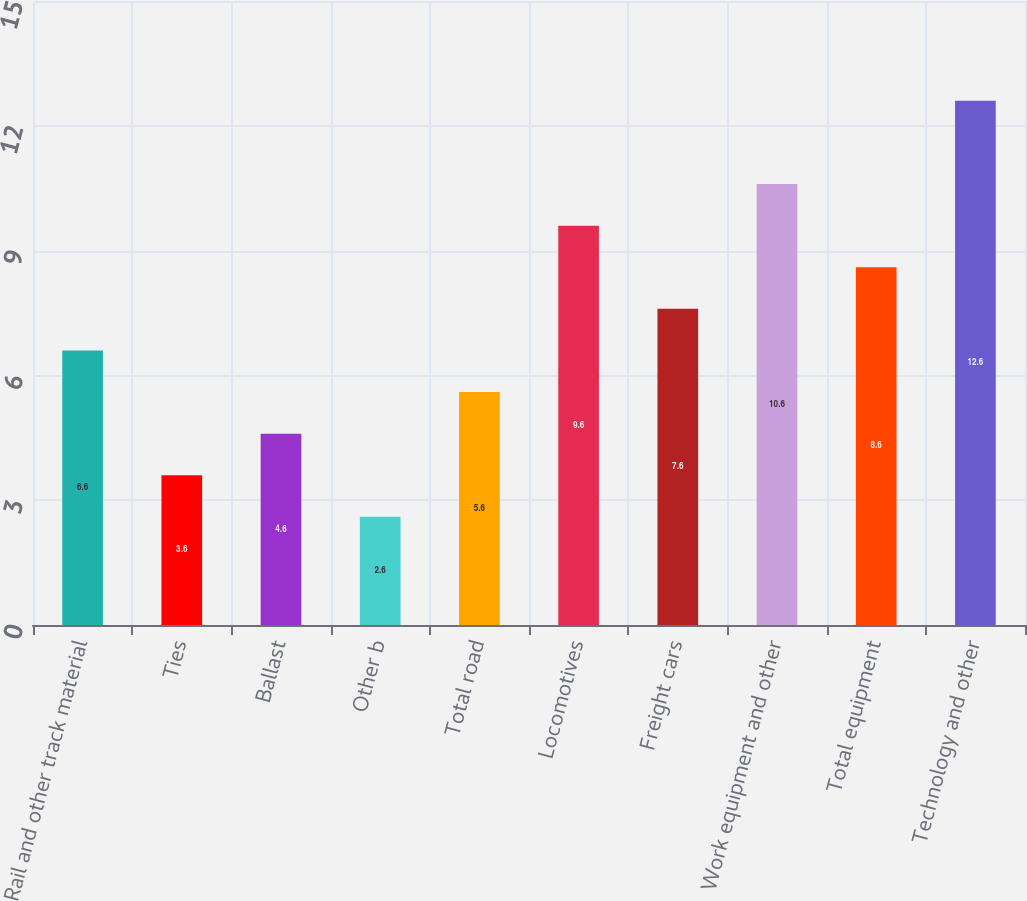Convert chart to OTSL. <chart><loc_0><loc_0><loc_500><loc_500><bar_chart><fcel>Rail and other track material<fcel>Ties<fcel>Ballast<fcel>Other b<fcel>Total road<fcel>Locomotives<fcel>Freight cars<fcel>Work equipment and other<fcel>Total equipment<fcel>Technology and other<nl><fcel>6.6<fcel>3.6<fcel>4.6<fcel>2.6<fcel>5.6<fcel>9.6<fcel>7.6<fcel>10.6<fcel>8.6<fcel>12.6<nl></chart> 